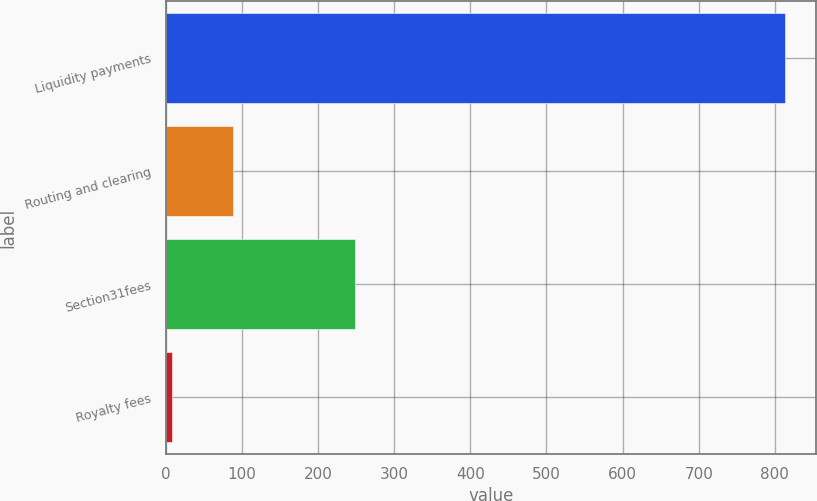Convert chart to OTSL. <chart><loc_0><loc_0><loc_500><loc_500><bar_chart><fcel>Liquidity payments<fcel>Routing and clearing<fcel>Section31fees<fcel>Royalty fees<nl><fcel>813.9<fcel>88.77<fcel>248.2<fcel>8.2<nl></chart> 